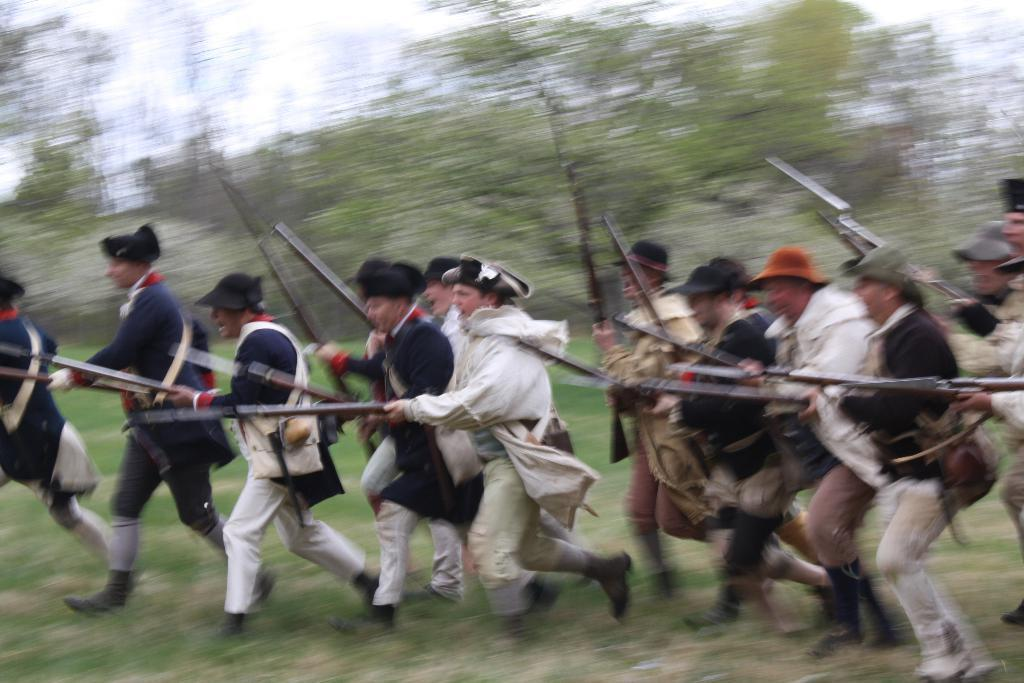What are the people in the image holding? The people in the image are holding weapons. What are the people doing with the weapons? The people are running on the ground while holding the weapons. What can be seen in the background of the image? There are trees and the sky visible in the background of the image. What type of wool can be seen floating in the sea in the image? There is no wool or sea present in the image; it features people holding weapons and running on the ground with trees and the sky visible in the background. 